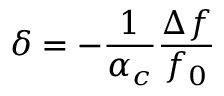<formula> <loc_0><loc_0><loc_500><loc_500>\delta = - \frac { 1 } { \alpha _ { c } } \frac { \Delta f } { f _ { 0 } }</formula> 